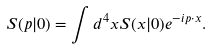<formula> <loc_0><loc_0><loc_500><loc_500>S ( p | 0 ) = \int d ^ { 4 } x S ( x | 0 ) e ^ { - i p \cdot x } .</formula> 